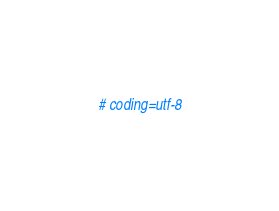<code> <loc_0><loc_0><loc_500><loc_500><_Python_># coding=utf-8</code> 